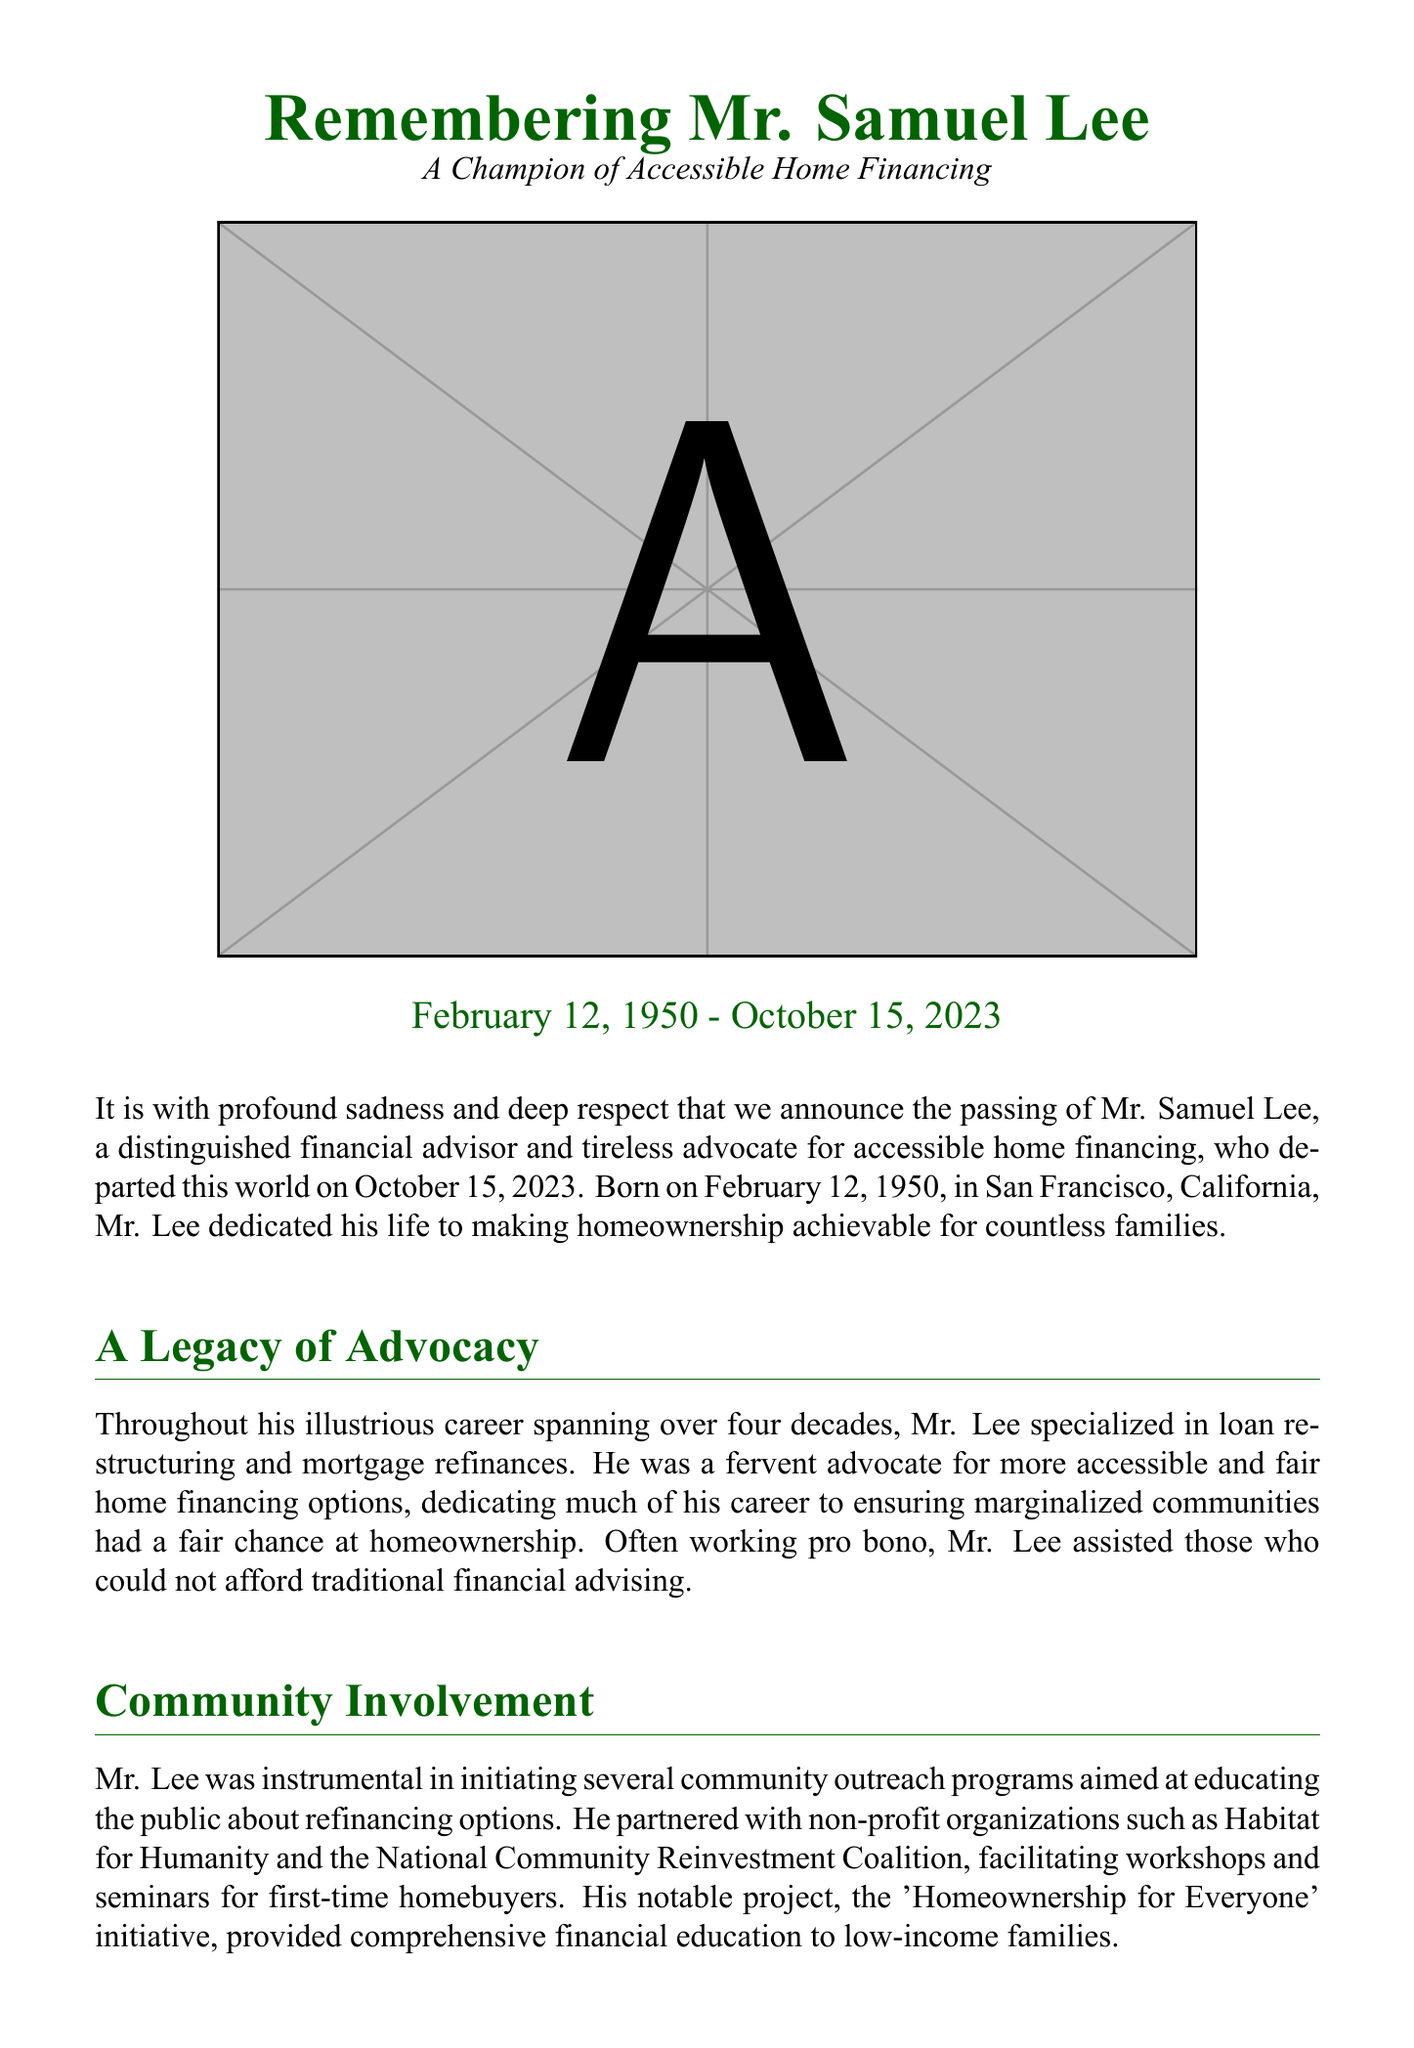What was Mr. Samuel Lee's birth date? The document states that Mr. Samuel Lee was born on February 12, 1950.
Answer: February 12, 1950 When did Mr. Lee pass away? The document mentions that Mr. Lee departed this world on October 15, 2023.
Answer: October 15, 2023 What was the main focus of Mr. Lee's professional career? The document highlights that Mr. Lee specialized in loan restructuring and mortgage refinances.
Answer: Loan restructuring and mortgage refinances What initiative did Mr. Lee lead for low-income families? The document refers to his notable project, the 'Homeownership for Everyone' initiative.
Answer: Homeownership for Everyone Which non-profit organization is mentioned in relation to Mr. Lee's community outreach? The document lists Habitat for Humanity as one of the organizations he partnered with.
Answer: Habitat for Humanity What characteristic is emphasized about Mr. Lee's approach to clients? The document states he treated each client with dignity and respect.
Answer: Dignity and respect How many grandchildren did Mr. Lee have? The document specifies that Mr. Lee is survived by three grandchildren.
Answer: Three What personal hobby did Mr. Lee enjoy? The document mentions that he was an avid gardener.
Answer: Gardening 